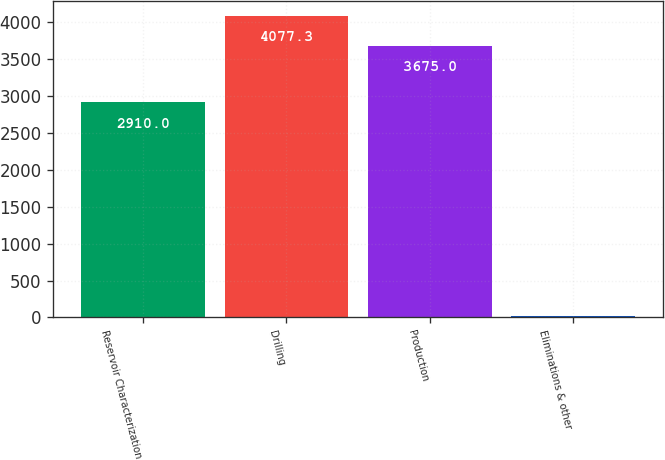Convert chart to OTSL. <chart><loc_0><loc_0><loc_500><loc_500><bar_chart><fcel>Reservoir Characterization<fcel>Drilling<fcel>Production<fcel>Eliminations & other<nl><fcel>2910<fcel>4077.3<fcel>3675<fcel>25<nl></chart> 